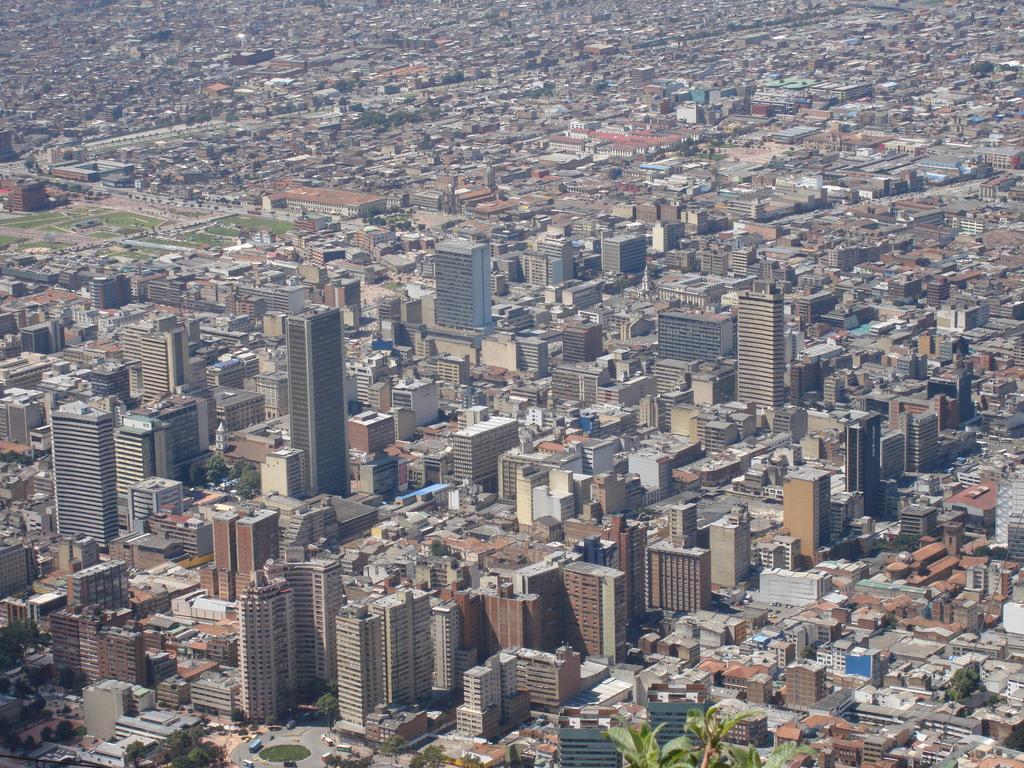Please provide a concise description of this image. This is an aerial view of where we can see buildings, tower buildings, road and trees. 